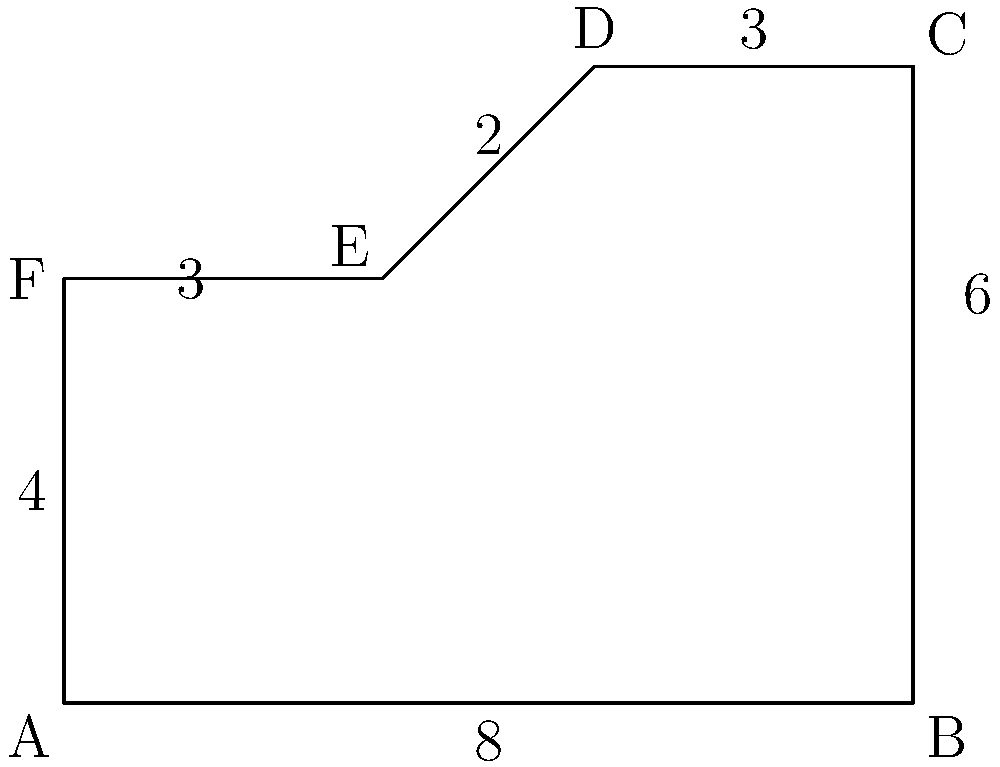A new multi-purpose facility for veteran reintegration programs is proposed with a layout as shown in the figure. The facility will include job training areas, counseling spaces, and recreational zones. Calculate the total area of the facility to determine its capacity for serving veterans. All measurements are in units of 10 meters. To calculate the area of this irregular polygon, we can divide it into simpler shapes:

1. Rectangle ABCF:
   Area = 8 * 4 = 32 square units

2. Right triangle FDE:
   Base = 5 - 3 = 2
   Height = 6 - 4 = 2
   Area = (1/2) * 2 * 2 = 2 square units

Therefore, the total area is:

$$\text{Total Area} = \text{Area of Rectangle} + \text{Area of Triangle}$$
$$\text{Total Area} = 32 + 2 = 34 \text{ square units}$$

Since each unit represents 10 meters:
$$\text{Actual Area} = 34 * 10^2 = 3400 \text{ square meters}$$
Answer: 3400 square meters 